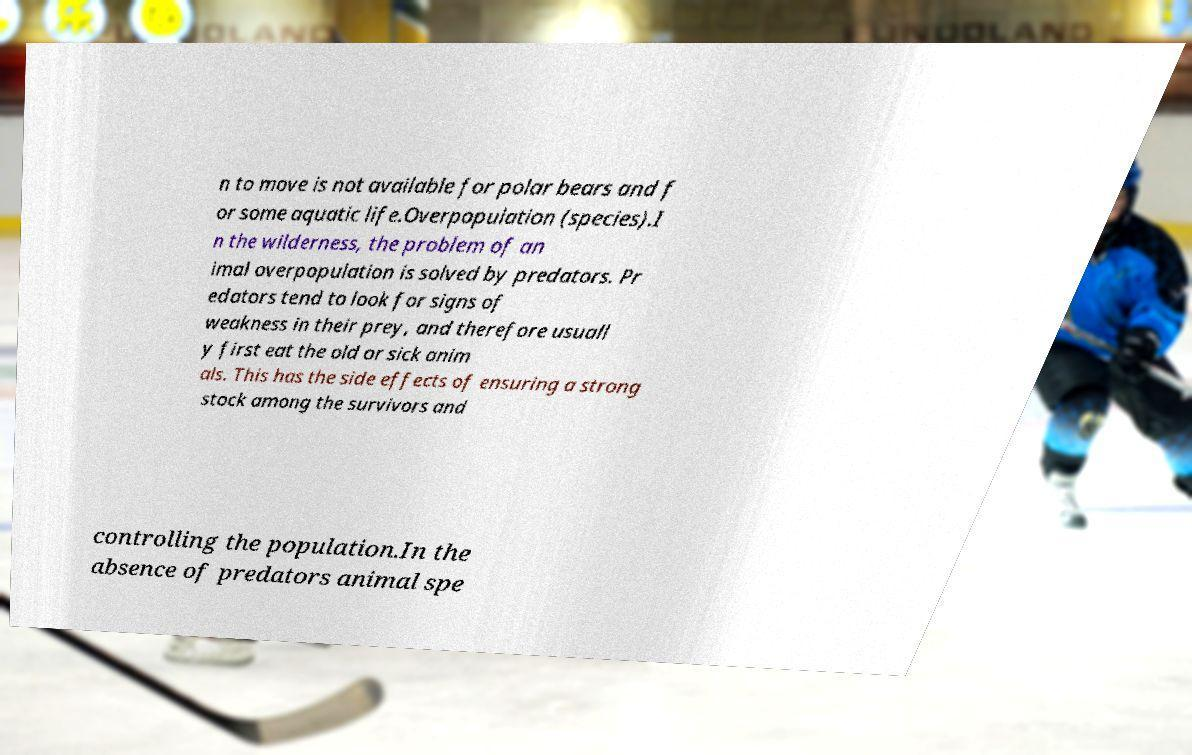Please identify and transcribe the text found in this image. n to move is not available for polar bears and f or some aquatic life.Overpopulation (species).I n the wilderness, the problem of an imal overpopulation is solved by predators. Pr edators tend to look for signs of weakness in their prey, and therefore usuall y first eat the old or sick anim als. This has the side effects of ensuring a strong stock among the survivors and controlling the population.In the absence of predators animal spe 